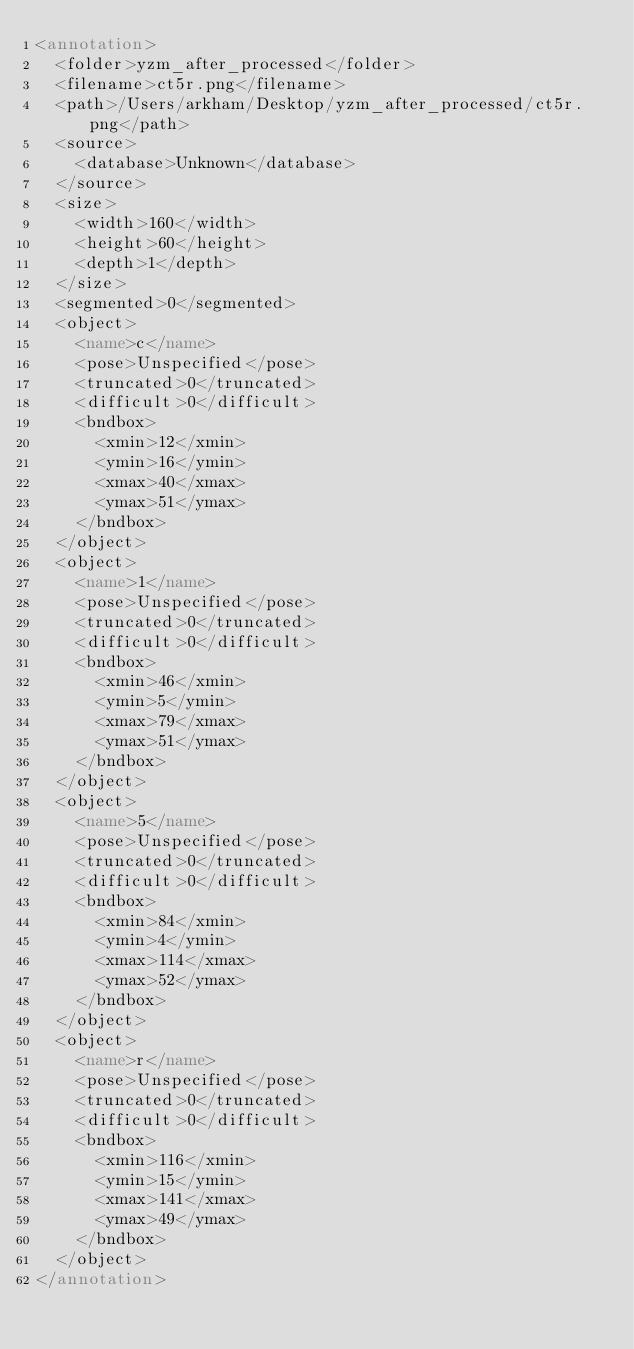Convert code to text. <code><loc_0><loc_0><loc_500><loc_500><_XML_><annotation>
	<folder>yzm_after_processed</folder>
	<filename>ct5r.png</filename>
	<path>/Users/arkham/Desktop/yzm_after_processed/ct5r.png</path>
	<source>
		<database>Unknown</database>
	</source>
	<size>
		<width>160</width>
		<height>60</height>
		<depth>1</depth>
	</size>
	<segmented>0</segmented>
	<object>
		<name>c</name>
		<pose>Unspecified</pose>
		<truncated>0</truncated>
		<difficult>0</difficult>
		<bndbox>
			<xmin>12</xmin>
			<ymin>16</ymin>
			<xmax>40</xmax>
			<ymax>51</ymax>
		</bndbox>
	</object>
	<object>
		<name>1</name>
		<pose>Unspecified</pose>
		<truncated>0</truncated>
		<difficult>0</difficult>
		<bndbox>
			<xmin>46</xmin>
			<ymin>5</ymin>
			<xmax>79</xmax>
			<ymax>51</ymax>
		</bndbox>
	</object>
	<object>
		<name>5</name>
		<pose>Unspecified</pose>
		<truncated>0</truncated>
		<difficult>0</difficult>
		<bndbox>
			<xmin>84</xmin>
			<ymin>4</ymin>
			<xmax>114</xmax>
			<ymax>52</ymax>
		</bndbox>
	</object>
	<object>
		<name>r</name>
		<pose>Unspecified</pose>
		<truncated>0</truncated>
		<difficult>0</difficult>
		<bndbox>
			<xmin>116</xmin>
			<ymin>15</ymin>
			<xmax>141</xmax>
			<ymax>49</ymax>
		</bndbox>
	</object>
</annotation>
</code> 